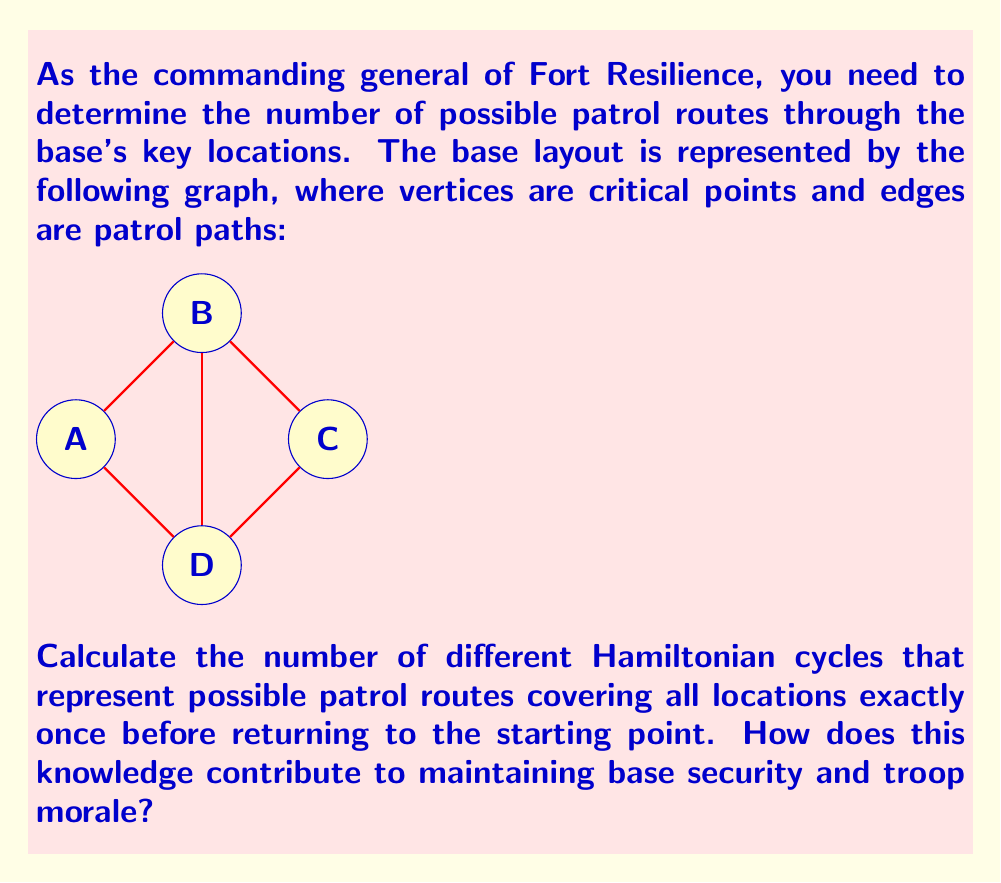Help me with this question. To solve this problem, we'll use graph theory concepts, specifically Hamiltonian cycles.

Step 1: Identify the graph properties
- The graph has 4 vertices (A, B, C, D)
- It is an undirected graph
- All vertices have a degree of 3

Step 2: Enumerate possible Hamiltonian cycles
A Hamiltonian cycle visits each vertex exactly once and returns to the starting point. Let's list all possible cycles:

1. A → B → C → D → A
2. A → B → D → C → A
3. A → D → B → C → A
4. A → D → C → B → A

Step 3: Verify the count
We can verify that these are all possible cycles by considering rotations and reverse orders:
- Each cycle can start from any of the 4 vertices (4 rotations)
- Each cycle can be traversed in reverse order

This gives us 4 unique cycles, as listed above.

Step 4: Interpret the result
Having 4 different patrol routes allows for:
1. Unpredictability in patrol patterns, enhancing security
2. Equal distribution of patrol duties among troops
3. Variety in routes, potentially improving troop morale and alertness

This knowledge contributes to base security by allowing for strategic rotation of patrol routes, making it difficult for potential intruders to predict patrol patterns. It also aids in maintaining troop morale by providing variety in duties and ensuring equal distribution of responsibilities among patrol units.
Answer: 4 Hamiltonian cycles 